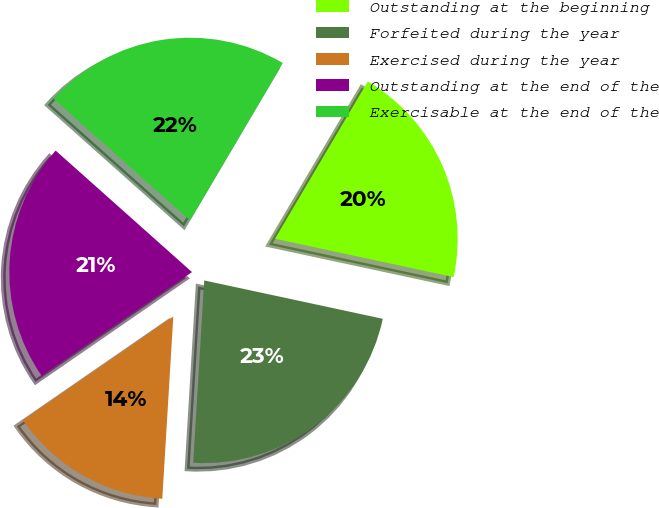Convert chart. <chart><loc_0><loc_0><loc_500><loc_500><pie_chart><fcel>Outstanding at the beginning<fcel>Forfeited during the year<fcel>Exercised during the year<fcel>Outstanding at the end of the<fcel>Exercisable at the end of the<nl><fcel>19.89%<fcel>22.6%<fcel>14.43%<fcel>21.2%<fcel>21.9%<nl></chart> 